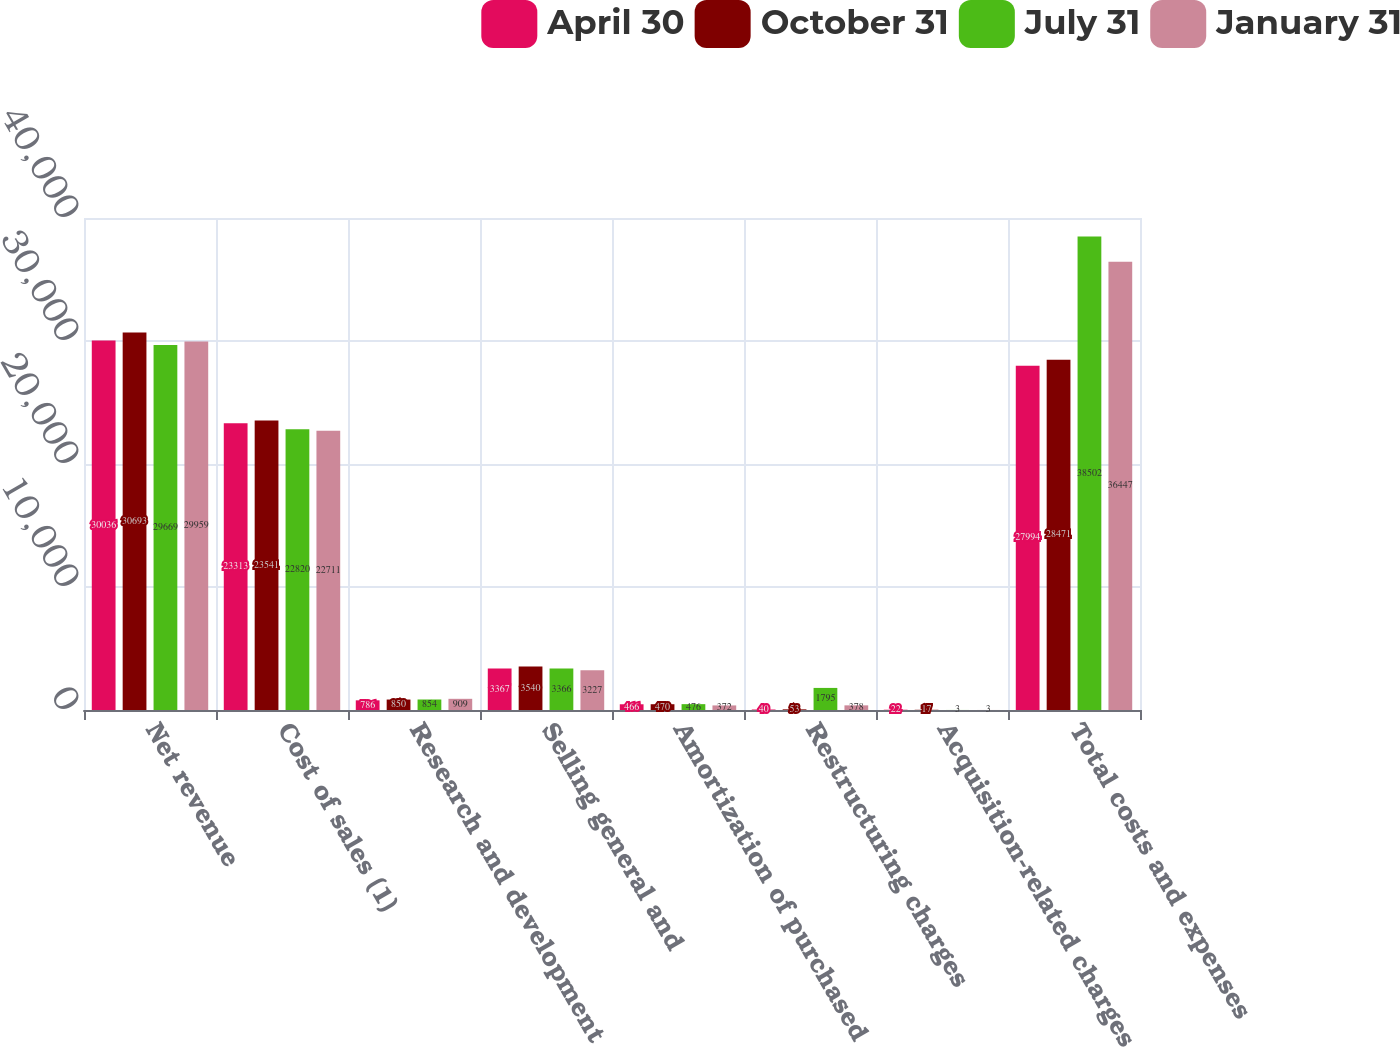Convert chart to OTSL. <chart><loc_0><loc_0><loc_500><loc_500><stacked_bar_chart><ecel><fcel>Net revenue<fcel>Cost of sales (1)<fcel>Research and development<fcel>Selling general and<fcel>Amortization of purchased<fcel>Restructuring charges<fcel>Acquisition-related charges<fcel>Total costs and expenses<nl><fcel>April 30<fcel>30036<fcel>23313<fcel>786<fcel>3367<fcel>466<fcel>40<fcel>22<fcel>27994<nl><fcel>October 31<fcel>30693<fcel>23541<fcel>850<fcel>3540<fcel>470<fcel>53<fcel>17<fcel>28471<nl><fcel>July 31<fcel>29669<fcel>22820<fcel>854<fcel>3366<fcel>476<fcel>1795<fcel>3<fcel>38502<nl><fcel>January 31<fcel>29959<fcel>22711<fcel>909<fcel>3227<fcel>372<fcel>378<fcel>3<fcel>36447<nl></chart> 